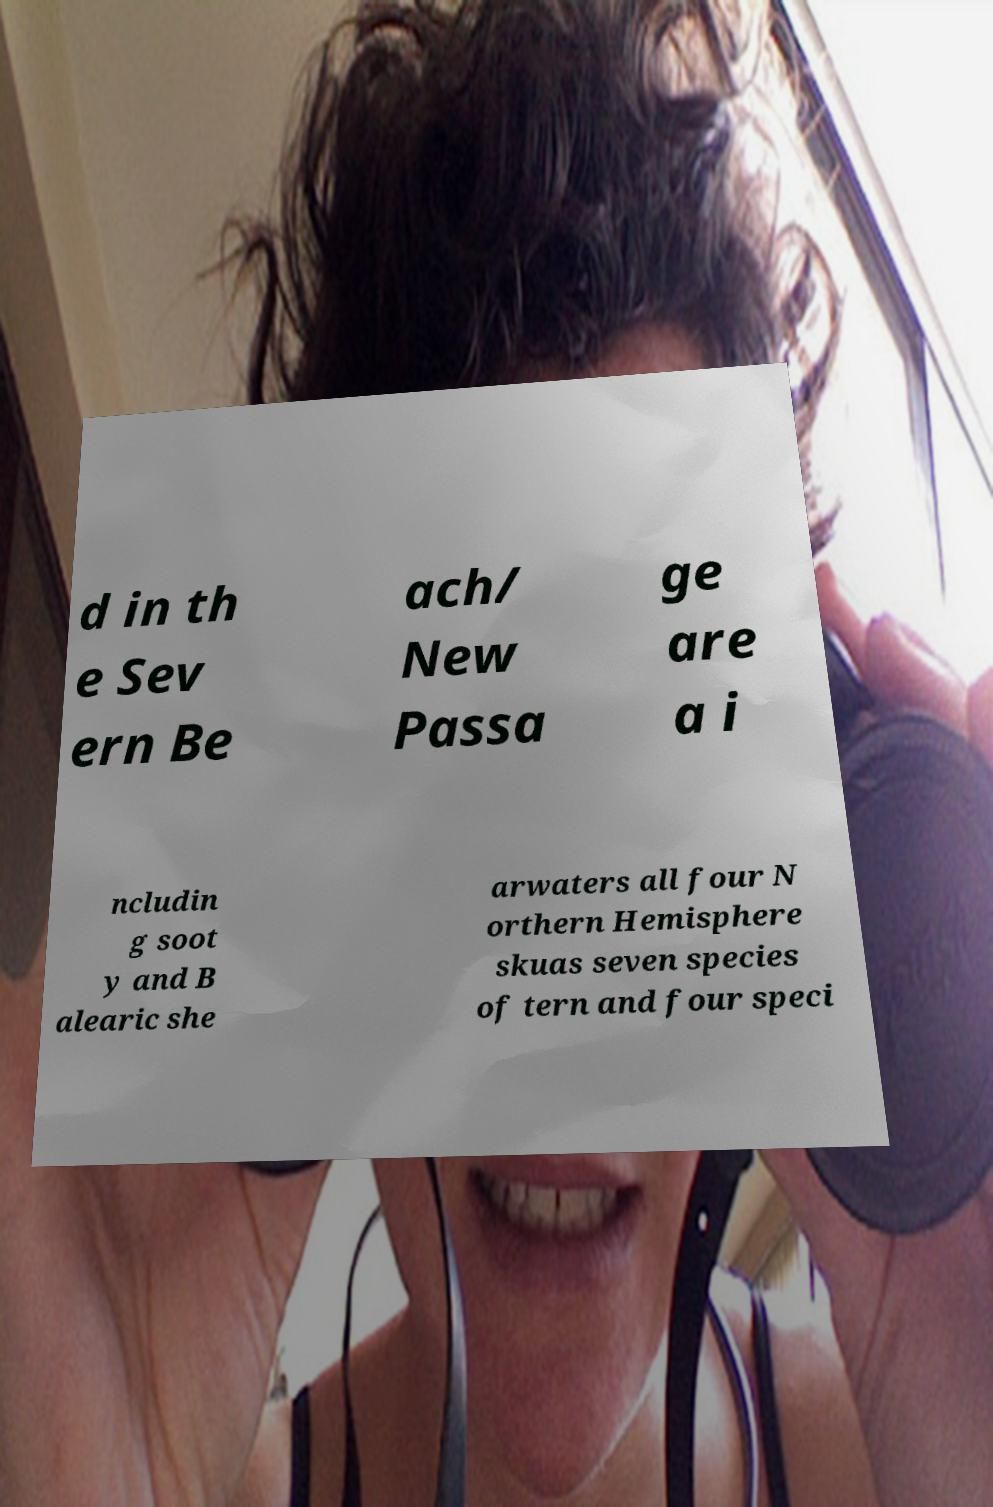Can you read and provide the text displayed in the image?This photo seems to have some interesting text. Can you extract and type it out for me? d in th e Sev ern Be ach/ New Passa ge are a i ncludin g soot y and B alearic she arwaters all four N orthern Hemisphere skuas seven species of tern and four speci 